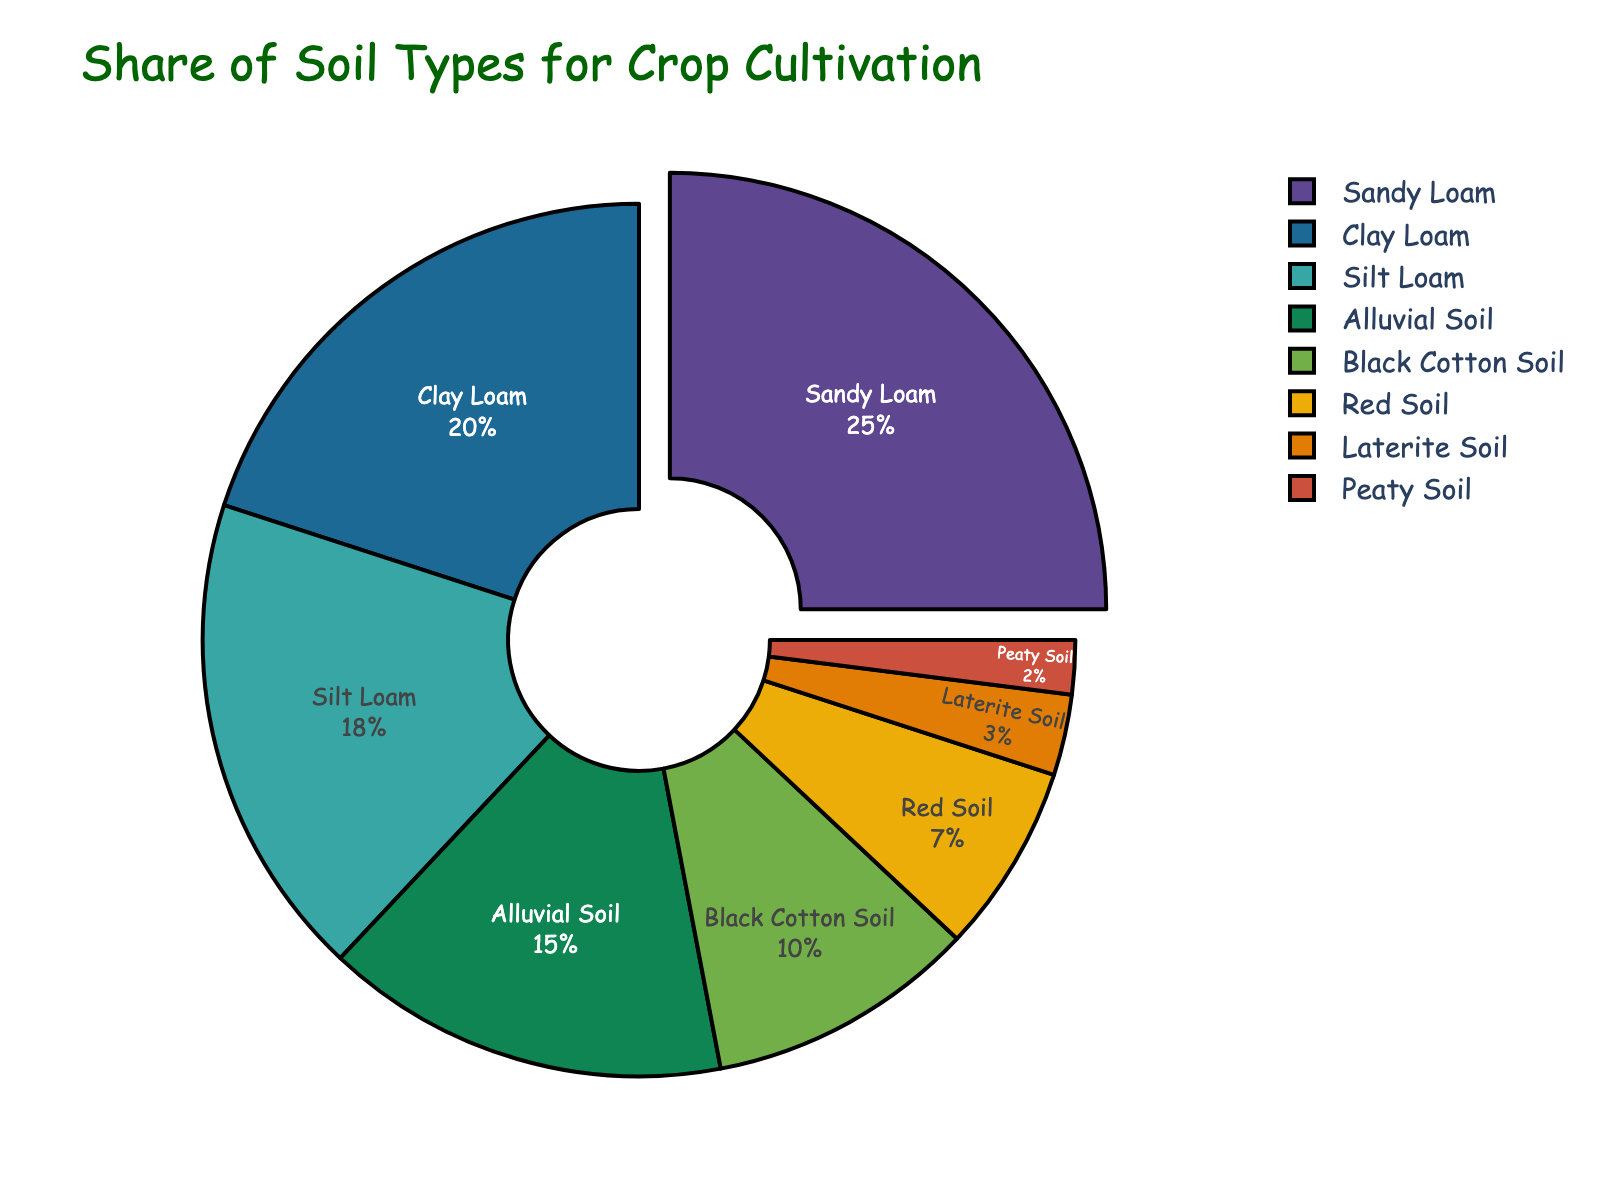How many different soil types are shown in the pie chart? To find the number of soil types, we simply count each unique segment in the pie chart. There are 8 different segments.
Answer: 8 Which soil type has the largest share in crop cultivation, and by how much? The largest segment in the pie chart represents the soil type with the highest percentage. Sandy Loam is the largest segment at 25%.
Answer: Sandy Loam, 25% What is the combined percentage of Silt Loam and Clay Loam? To find the combined percentage, we add the individual percentages of Silt Loam (18%) and Clay Loam (20%). 18% + 20% = 38%.
Answer: 38% Which soil type has the smallest share in crop cultivation? The smallest segment in the pie chart represents the soil type with the lowest percentage. Peaty Soil is the smallest segment at 2%.
Answer: Peaty Soil, 2% Is the share of Black Cotton Soil greater than Red Soil? To compare these, we look at their respective segments in the pie chart. Black Cotton Soil has a share of 10%, while Red Soil has 7%. 10% is greater than 7%.
Answer: Yes How much larger is the percentage of Alluvial Soil compared to Laterite Soil? To find this, subtract the percentage of Laterite Soil (3%) from Alluvial Soil (15%). 15% - 3% = 12%.
Answer: 12% What is the difference in percentage between the largest and the smallest soil type shares? Subtract the percentage of Peaty Soil (2%) from Sandy Loam (25%). 25% - 2% = 23%.
Answer: 23% What is the total percentage of Red Soil, Laterite Soil, and Peaty Soil? Add the percentages of Red Soil (7%), Laterite Soil (3%), and Peaty Soil (2%). 7% + 3% + 2% = 12%.
Answer: 12% What percentage of soil types used is neither Sandy Loam nor Clay Loam? Subtract the combined percentage of Sandy Loam (25%) and Clay Loam (20%) from 100%. 100% - (25% + 20%) = 55%.
Answer: 55% Are there more soil types with a share greater or less than 10%? Count the number of soil types with percentages greater than 10% (Sandy Loam, Clay Loam, Silt Loam, Alluvial Soil) and those with less than or equal to 10% (Black Cotton Soil, Red Soil, Laterite Soil, Peaty Soil). There are 4 types with shares greater than 10% and 4 types with shares less or equal to 10%.
Answer: Equal 